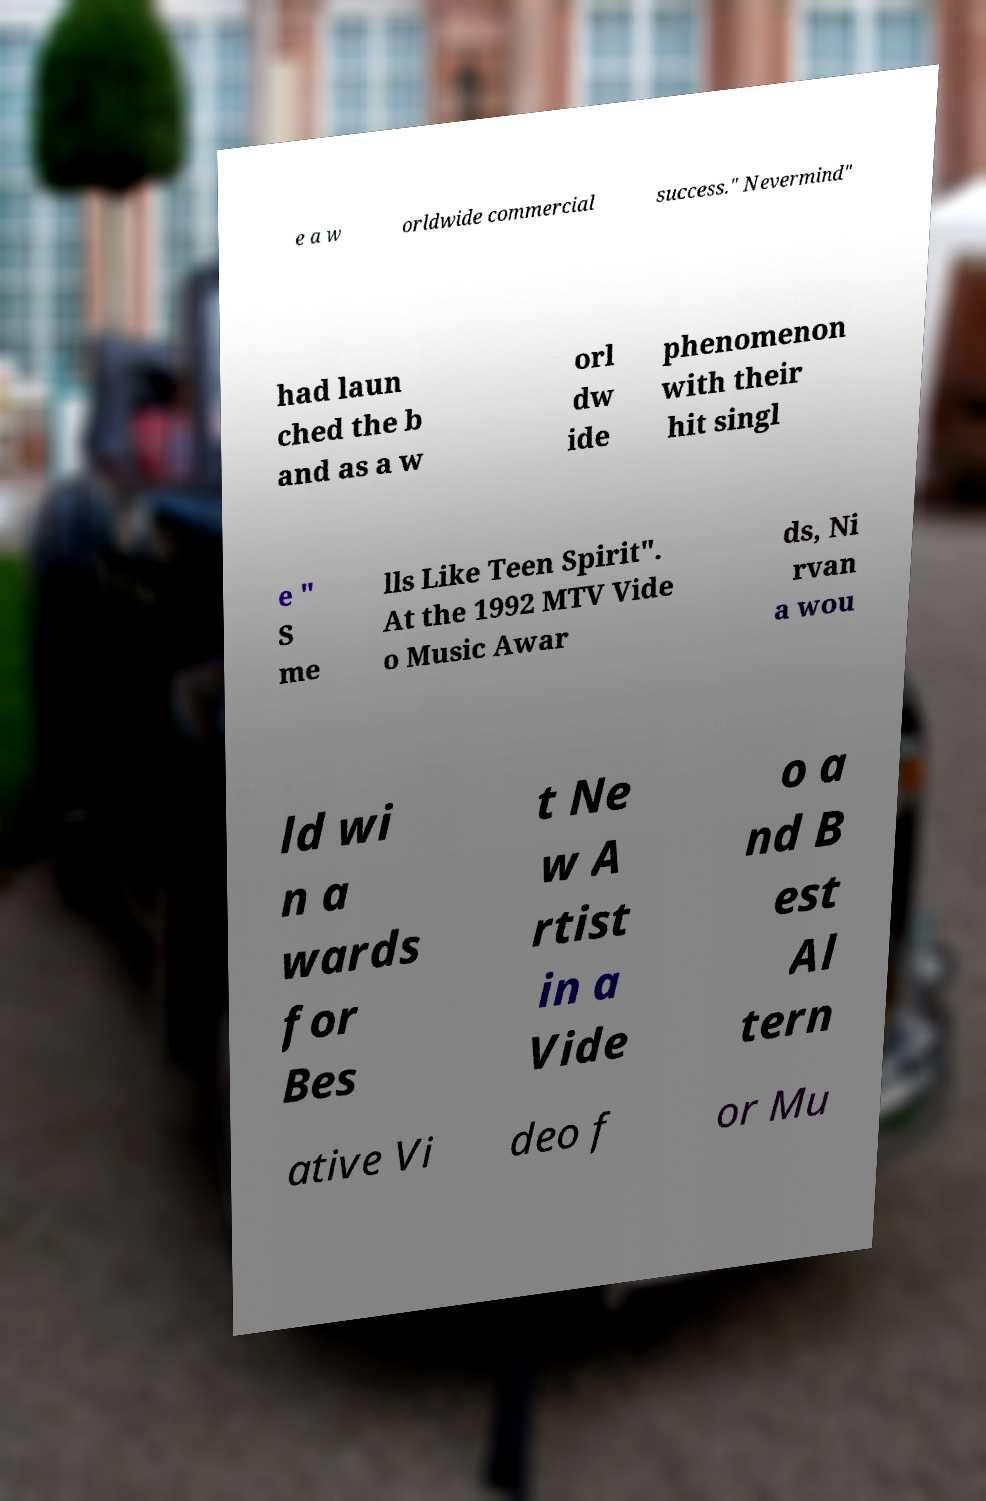Can you read and provide the text displayed in the image?This photo seems to have some interesting text. Can you extract and type it out for me? e a w orldwide commercial success." Nevermind" had laun ched the b and as a w orl dw ide phenomenon with their hit singl e " S me lls Like Teen Spirit". At the 1992 MTV Vide o Music Awar ds, Ni rvan a wou ld wi n a wards for Bes t Ne w A rtist in a Vide o a nd B est Al tern ative Vi deo f or Mu 